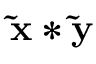Convert formula to latex. <formula><loc_0><loc_0><loc_500><loc_500>\widetilde { x } * \widetilde { y }</formula> 